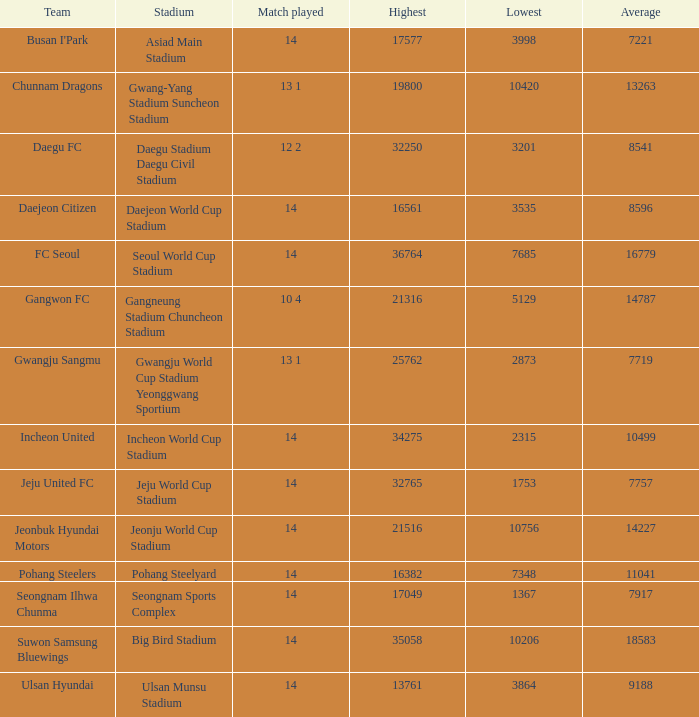What is the lowest when pohang steelyard is the stadium? 7348.0. 